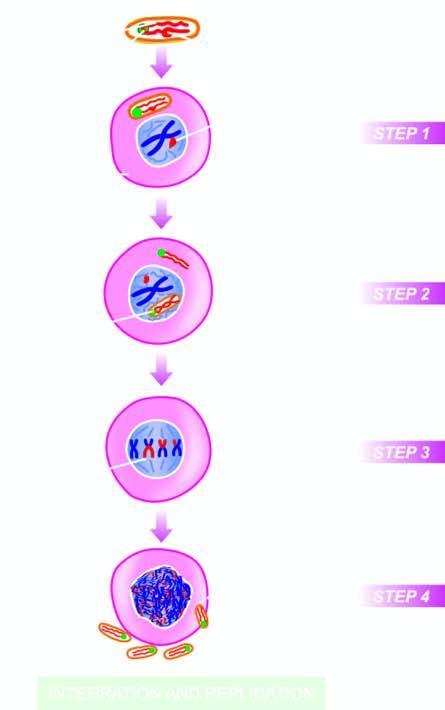re viral rna genome as well as reverse transcriptase released into the cytosol?
Answer the question using a single word or phrase. Yes 